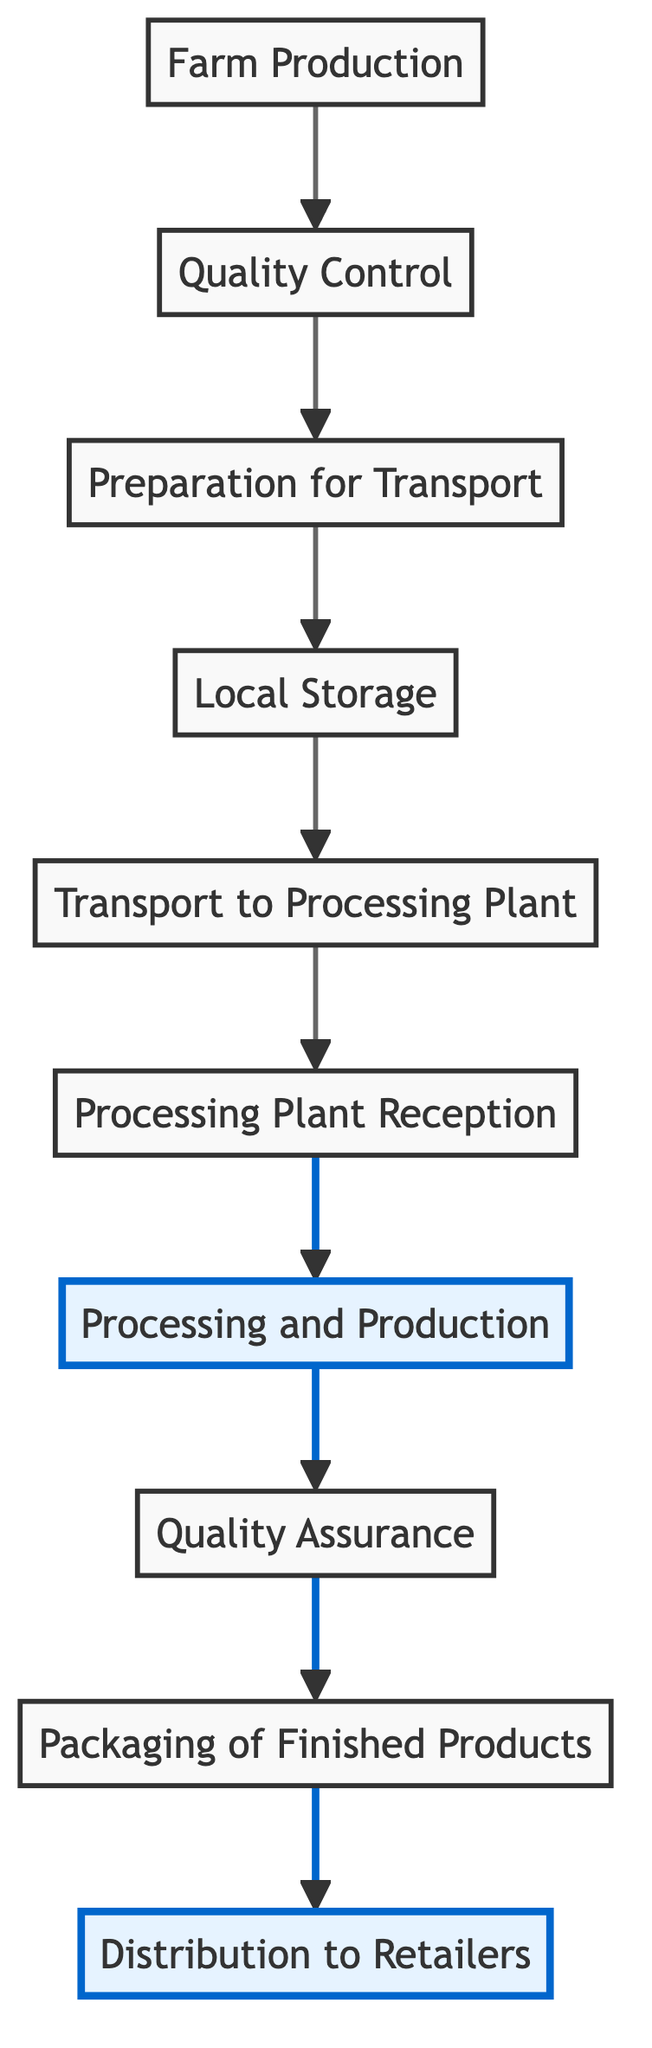What is the first step in the workflow? The first step is "Farm Production," where the natural ingredients are harvested and processed initially. This is the starting point of the flowchart as indicated at the bottom.
Answer: Farm Production How many steps are there in the workflow? By counting each specific element in the diagram, we find there are ten distinct steps listed from "Farm Production" to "Distribution to Retailers."
Answer: Ten Which step comes after "Quality Control"? After "Quality Control," the next step is "Preparation for Transport." The diagram indicates a direct flow from B (Quality Control) to C (Preparation for Transport).
Answer: Preparation for Transport What is the main function of the "Processing and Production" step? The main function is to blend, formulate, and convert the raw ingredients into laundry detergent and fabric softener products. This is explicitly stated in the description of G.
Answer: Blending and formulation How does "Local Storage" relate to "Transport to Processing Plant"? "Local Storage" is an intermediate step that stores the packaged ingredients before they are transported to the processing plant, indicating that storage is required before transport can occur.
Answer: Intermediate step What step follows "Quality Assurance"? The step that follows "Quality Assurance" is "Packaging of Finished Products." This progression directly flows from H to I in the diagram.
Answer: Packaging of Finished Products Which elements represent the points of quality validation in the workflow? The elements that represent quality validation points in the workflow are "Quality Control" and "Quality Assurance," both of which involve inspection and testing to maintain quality.
Answer: Quality Control and Quality Assurance What is the significance of the two emphasized steps in the diagram? The emphasized steps (Processing and Production, Distribution to Retailers) highlight critical stages in the workflow, indicating that they are key points for value addition and delivery in the process.
Answer: Critical stages What happens after ingredients are received at the processing plant? After the ingredients are received at the processing plant, they undergo "Processing and Production," where they are blended and formulated into final products. This is the next step highlighted in the flow.
Answer: Processing and Production 